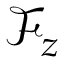<formula> <loc_0><loc_0><loc_500><loc_500>\mathcal { F } _ { z }</formula> 